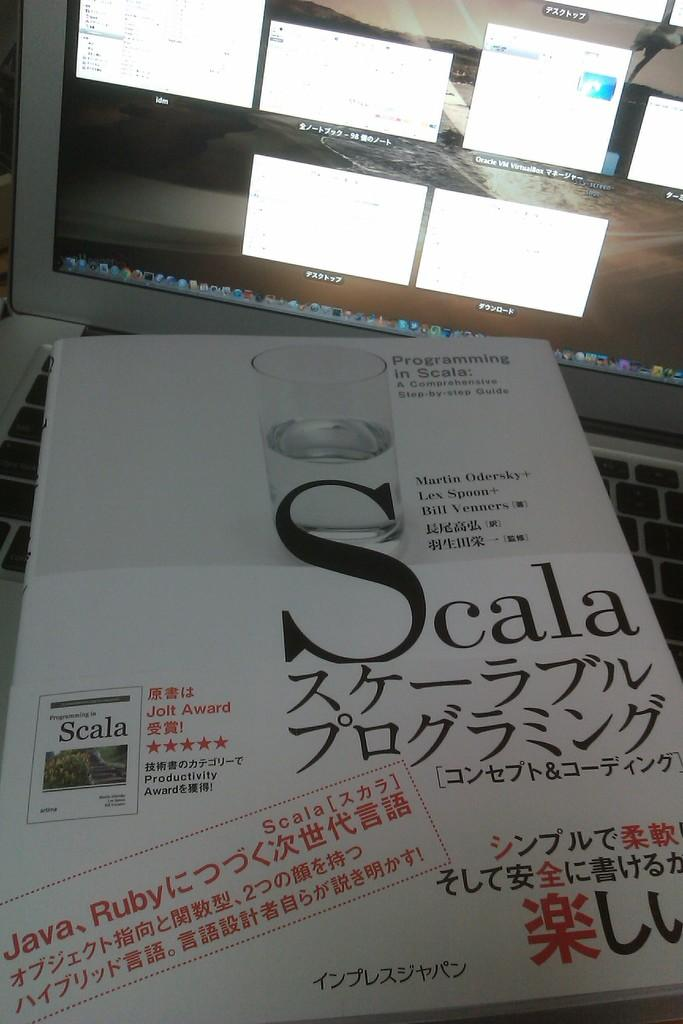<image>
Describe the image concisely. A book called Scala is on an Apple laptop. 